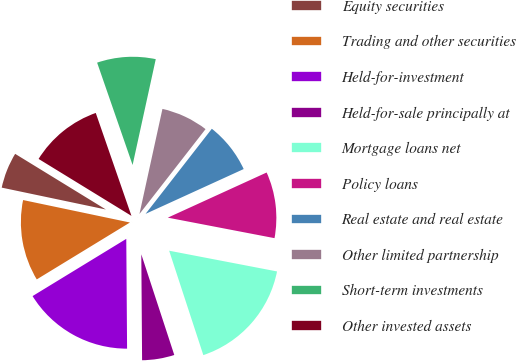Convert chart to OTSL. <chart><loc_0><loc_0><loc_500><loc_500><pie_chart><fcel>Equity securities<fcel>Trading and other securities<fcel>Held-for-investment<fcel>Held-for-sale principally at<fcel>Mortgage loans net<fcel>Policy loans<fcel>Real estate and real estate<fcel>Other limited partnership<fcel>Short-term investments<fcel>Other invested assets<nl><fcel>5.46%<fcel>12.02%<fcel>16.39%<fcel>4.92%<fcel>16.94%<fcel>9.84%<fcel>7.65%<fcel>7.1%<fcel>8.74%<fcel>10.93%<nl></chart> 